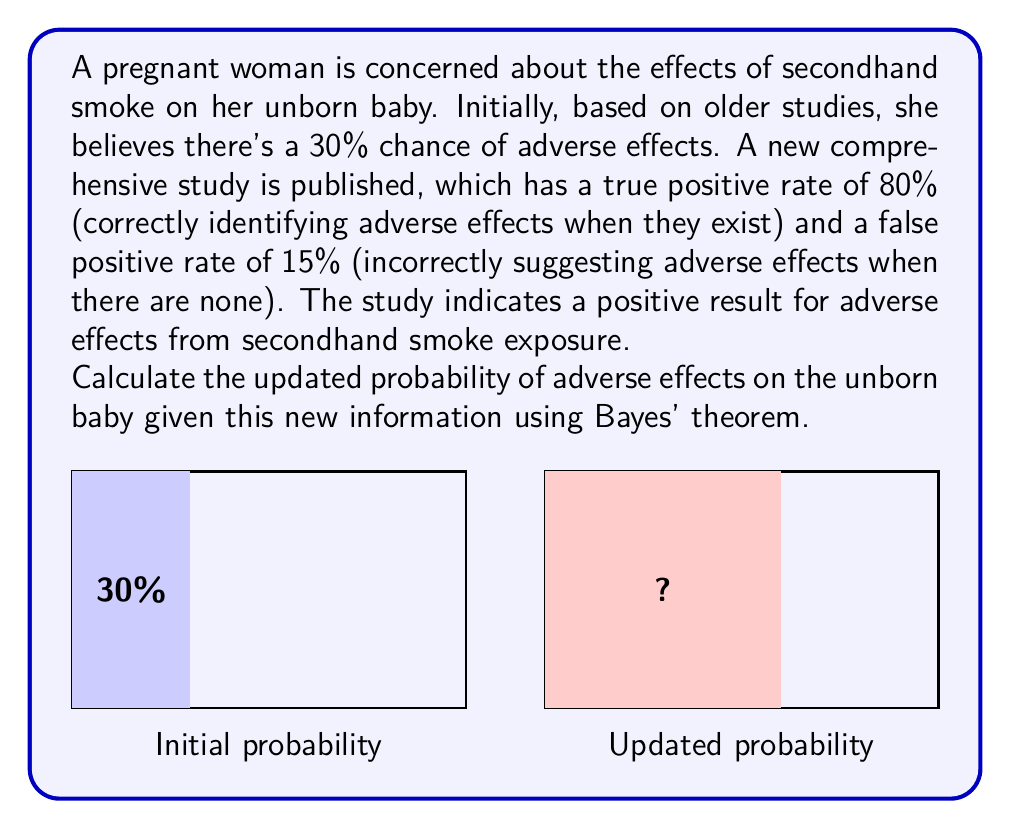Can you solve this math problem? Let's approach this problem step-by-step using Bayes' theorem:

1) Define our events:
   A: Adverse effects occur
   B: Study shows positive result

2) Given information:
   P(A) = 0.30 (initial probability of adverse effects)
   P(B|A) = 0.80 (true positive rate)
   P(B|not A) = 0.15 (false positive rate)

3) Bayes' theorem states:

   $$P(A|B) = \frac{P(B|A) \cdot P(A)}{P(B)}$$

4) We need to calculate P(B):
   P(B) = P(B|A) · P(A) + P(B|not A) · P(not A)
        = 0.80 · 0.30 + 0.15 · 0.70
        = 0.24 + 0.105
        = 0.345

5) Now we can apply Bayes' theorem:

   $$P(A|B) = \frac{0.80 \cdot 0.30}{0.345} = \frac{0.24}{0.345} \approx 0.6957$$

6) Convert to percentage: 0.6957 * 100 ≈ 69.57%

Therefore, given the positive result from the new study, the updated probability of adverse effects on the unborn baby is approximately 69.57%.
Answer: 69.57% 